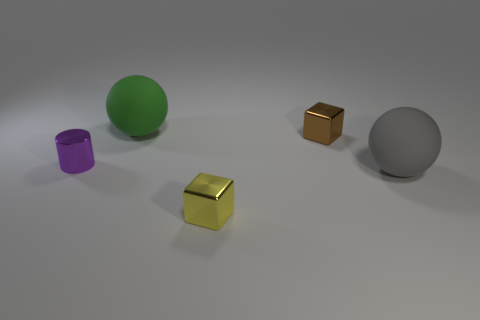Is there a yellow matte cylinder of the same size as the green rubber sphere?
Offer a very short reply. No. There is a block that is to the left of the small brown block; what is its size?
Give a very brief answer. Small. Is there a small brown thing left of the metal cube that is in front of the large gray ball?
Make the answer very short. No. How many other things are there of the same shape as the big green rubber object?
Offer a terse response. 1. Is the shape of the large gray thing the same as the big green object?
Keep it short and to the point. Yes. What color is the thing that is left of the large gray sphere and in front of the metal cylinder?
Your response must be concise. Yellow. What number of tiny objects are either rubber objects or metal cubes?
Make the answer very short. 2. Is there anything else that has the same color as the cylinder?
Provide a succinct answer. No. The object that is on the left side of the large ball that is on the left side of the rubber object that is in front of the small brown object is made of what material?
Make the answer very short. Metal. What number of matte things are yellow objects or tiny purple things?
Offer a terse response. 0. 